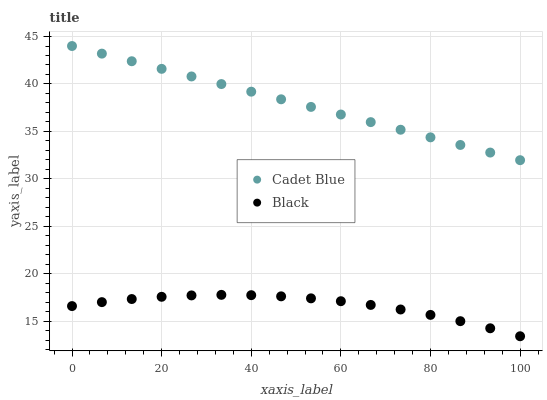Does Black have the minimum area under the curve?
Answer yes or no. Yes. Does Cadet Blue have the maximum area under the curve?
Answer yes or no. Yes. Does Black have the maximum area under the curve?
Answer yes or no. No. Is Cadet Blue the smoothest?
Answer yes or no. Yes. Is Black the roughest?
Answer yes or no. Yes. Is Black the smoothest?
Answer yes or no. No. Does Black have the lowest value?
Answer yes or no. Yes. Does Cadet Blue have the highest value?
Answer yes or no. Yes. Does Black have the highest value?
Answer yes or no. No. Is Black less than Cadet Blue?
Answer yes or no. Yes. Is Cadet Blue greater than Black?
Answer yes or no. Yes. Does Black intersect Cadet Blue?
Answer yes or no. No. 